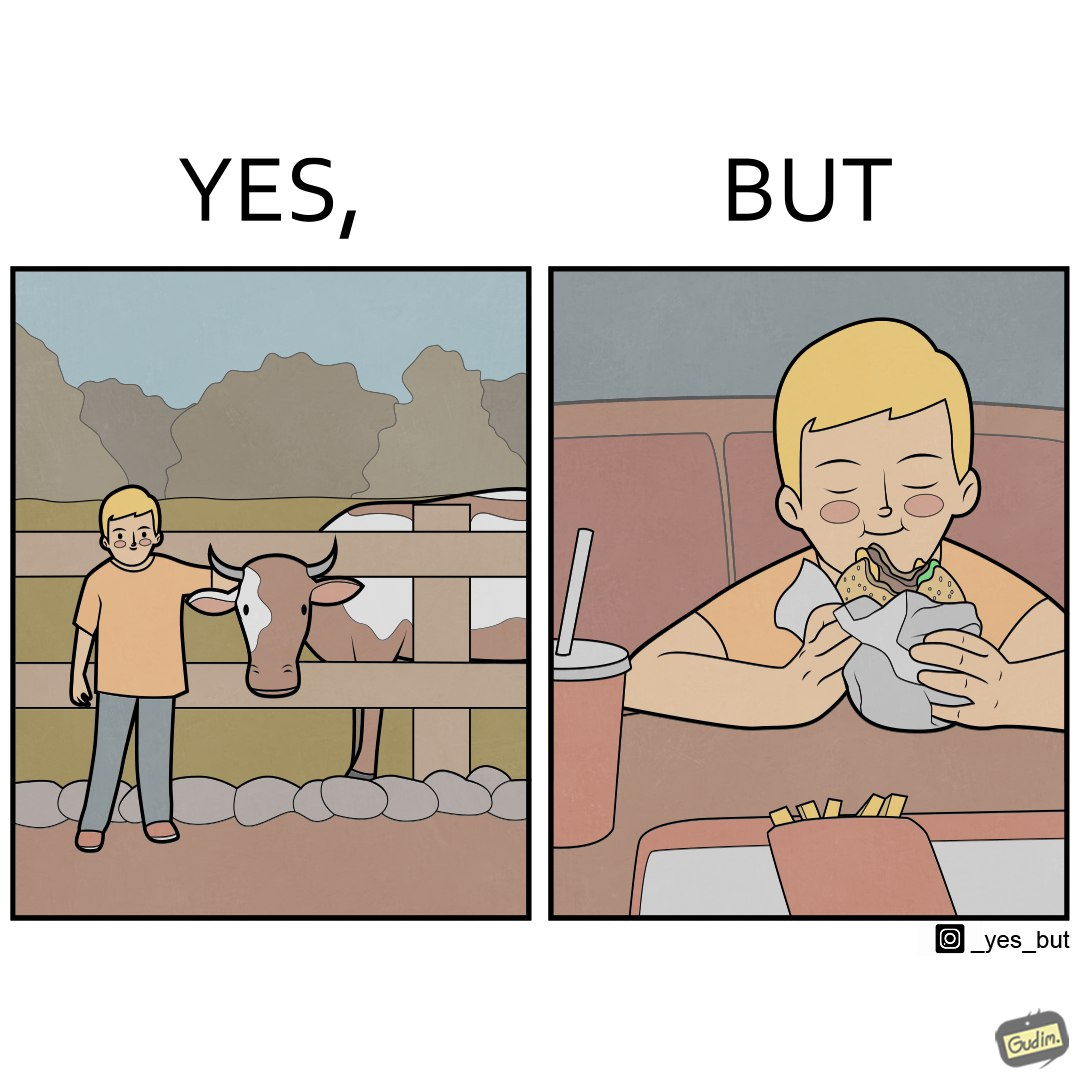What is the satirical meaning behind this image? The irony is that the boy is petting the cow to show that he cares about the animal, but then he also eats hamburgers made from the same cows 